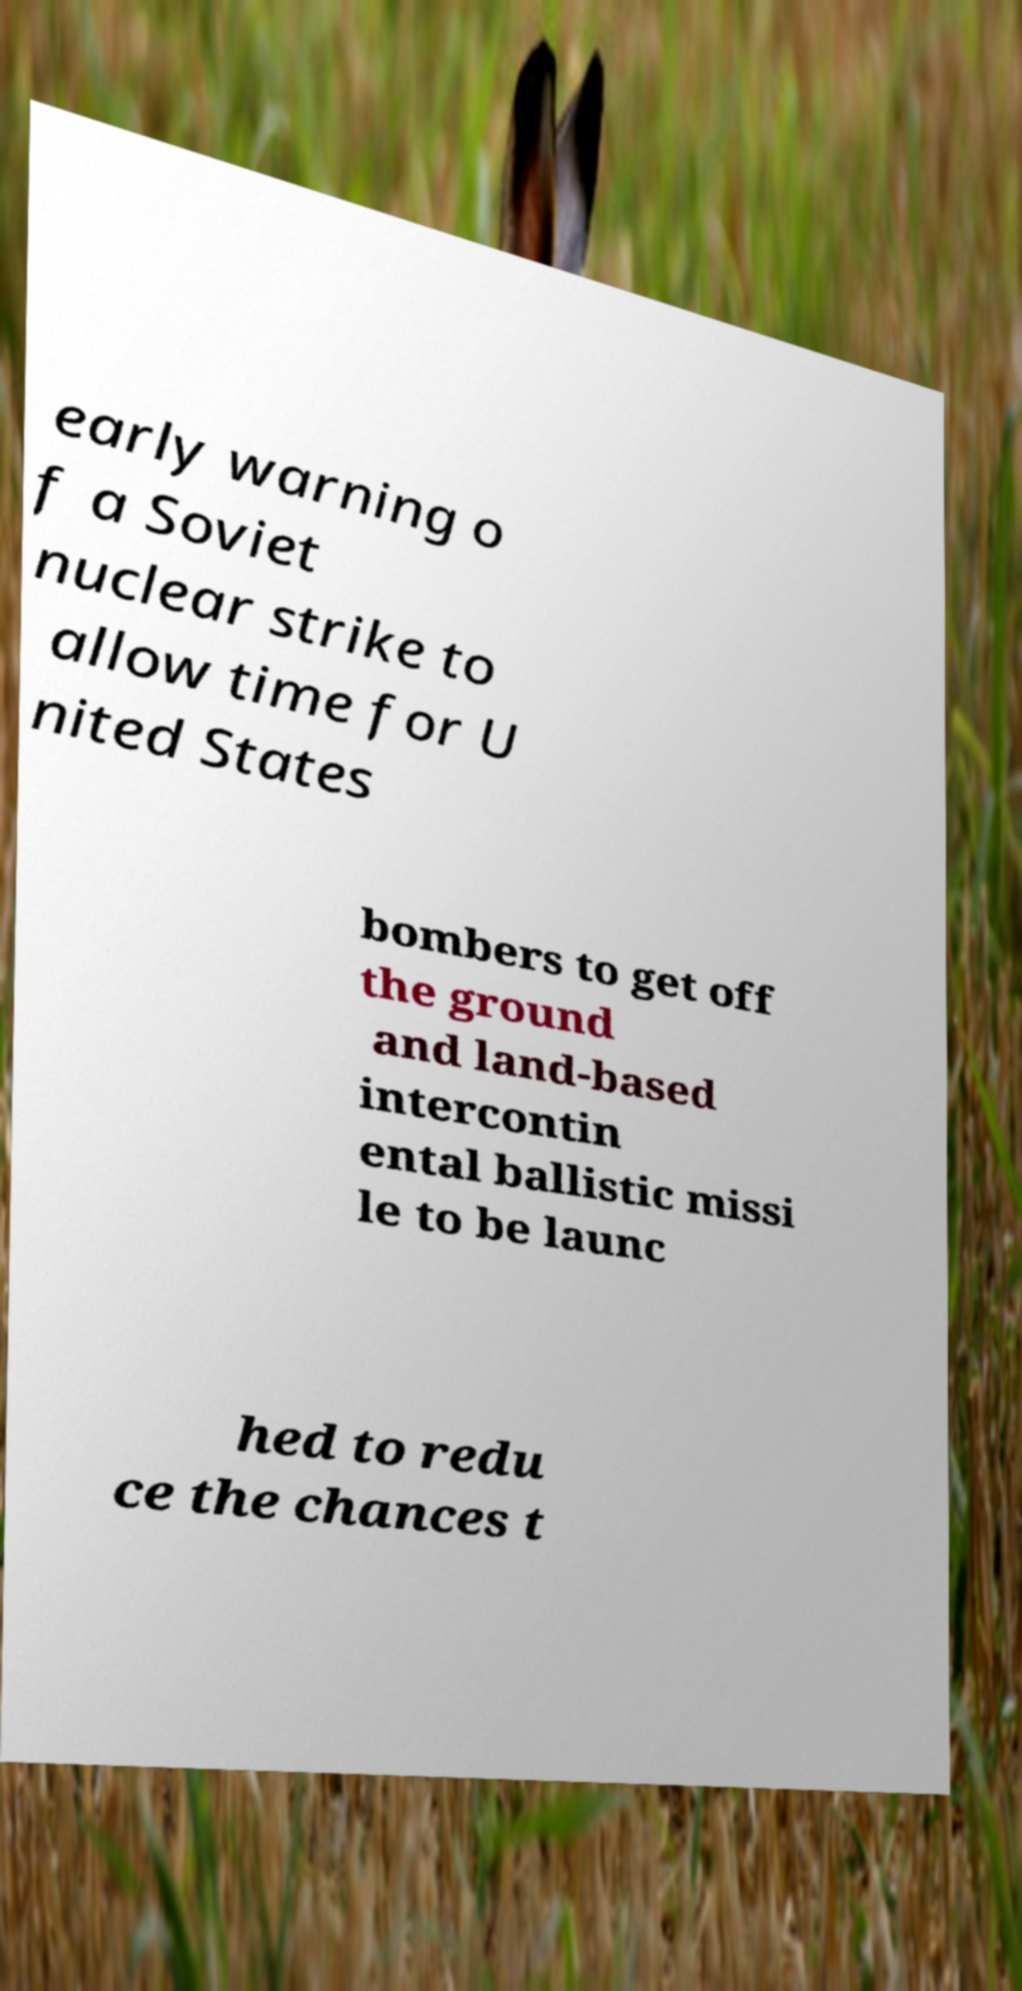Please identify and transcribe the text found in this image. early warning o f a Soviet nuclear strike to allow time for U nited States bombers to get off the ground and land-based intercontin ental ballistic missi le to be launc hed to redu ce the chances t 